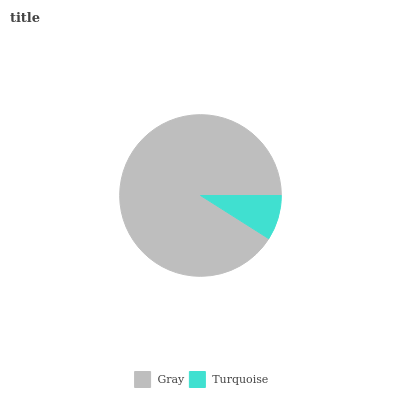Is Turquoise the minimum?
Answer yes or no. Yes. Is Gray the maximum?
Answer yes or no. Yes. Is Turquoise the maximum?
Answer yes or no. No. Is Gray greater than Turquoise?
Answer yes or no. Yes. Is Turquoise less than Gray?
Answer yes or no. Yes. Is Turquoise greater than Gray?
Answer yes or no. No. Is Gray less than Turquoise?
Answer yes or no. No. Is Gray the high median?
Answer yes or no. Yes. Is Turquoise the low median?
Answer yes or no. Yes. Is Turquoise the high median?
Answer yes or no. No. Is Gray the low median?
Answer yes or no. No. 